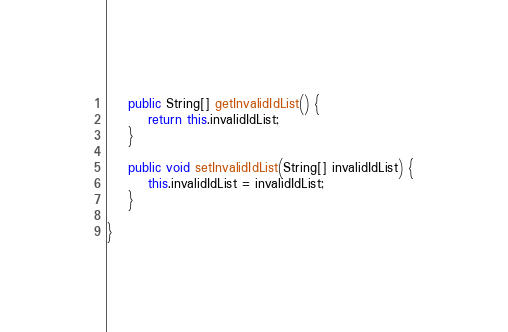<code> <loc_0><loc_0><loc_500><loc_500><_Java_>    public String[] getInvalidIdList() {
        return this.invalidIdList;
    }

    public void setInvalidIdList(String[] invalidIdList) {
        this.invalidIdList = invalidIdList;
    }

}
</code> 